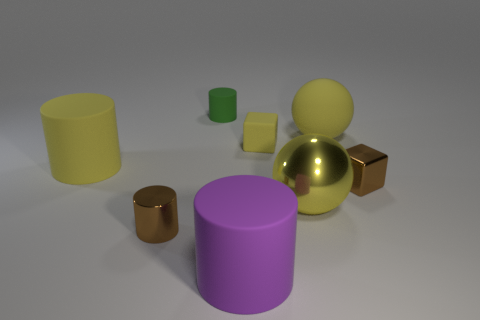What shape is the large metallic thing right of the brown thing that is on the left side of the yellow rubber sphere?
Give a very brief answer. Sphere. Is there any other thing that has the same color as the matte block?
Your answer should be very brief. Yes. There is a brown metal thing that is right of the small green matte cylinder; what is its shape?
Give a very brief answer. Cube. There is a matte thing that is both left of the large purple thing and in front of the large matte ball; what is its shape?
Ensure brevity in your answer.  Cylinder. How many blue objects are either tiny objects or large things?
Offer a very short reply. 0. There is a shiny thing that is on the right side of the large yellow shiny ball; is its color the same as the tiny shiny cylinder?
Provide a succinct answer. Yes. There is a cube in front of the big matte cylinder behind the purple cylinder; what size is it?
Make the answer very short. Small. There is a green cylinder that is the same size as the rubber cube; what material is it?
Make the answer very short. Rubber. What number of other things are there of the same size as the rubber block?
Offer a very short reply. 3. What number of cylinders are either blue things or big yellow shiny objects?
Give a very brief answer. 0. 